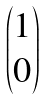<formula> <loc_0><loc_0><loc_500><loc_500>\begin{pmatrix} 1 \\ 0 \\ \end{pmatrix}</formula> 